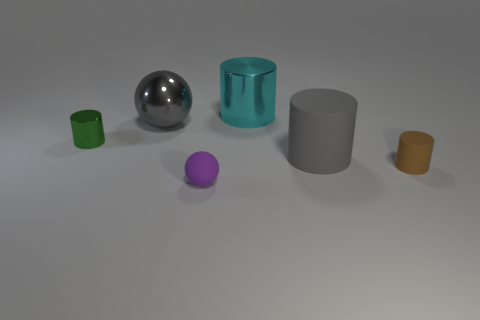How many large rubber cylinders are the same color as the metal sphere?
Your answer should be compact. 1. What number of objects are either tiny purple matte balls or things right of the tiny purple ball?
Keep it short and to the point. 4. The small ball is what color?
Offer a very short reply. Purple. What is the color of the shiny cylinder that is behind the small green metal thing?
Ensure brevity in your answer.  Cyan. There is a matte thing right of the big gray rubber object; how many green metallic cylinders are right of it?
Make the answer very short. 0. There is a gray ball; is its size the same as the thing to the left of the large sphere?
Your answer should be compact. No. Is there a green metal thing of the same size as the purple sphere?
Provide a short and direct response. Yes. What number of things are either tiny green cylinders or tiny green blocks?
Provide a short and direct response. 1. There is a green metal thing behind the large rubber object; does it have the same size as the ball that is in front of the tiny green metal thing?
Keep it short and to the point. Yes. Are there any other things of the same shape as the large matte object?
Keep it short and to the point. Yes. 